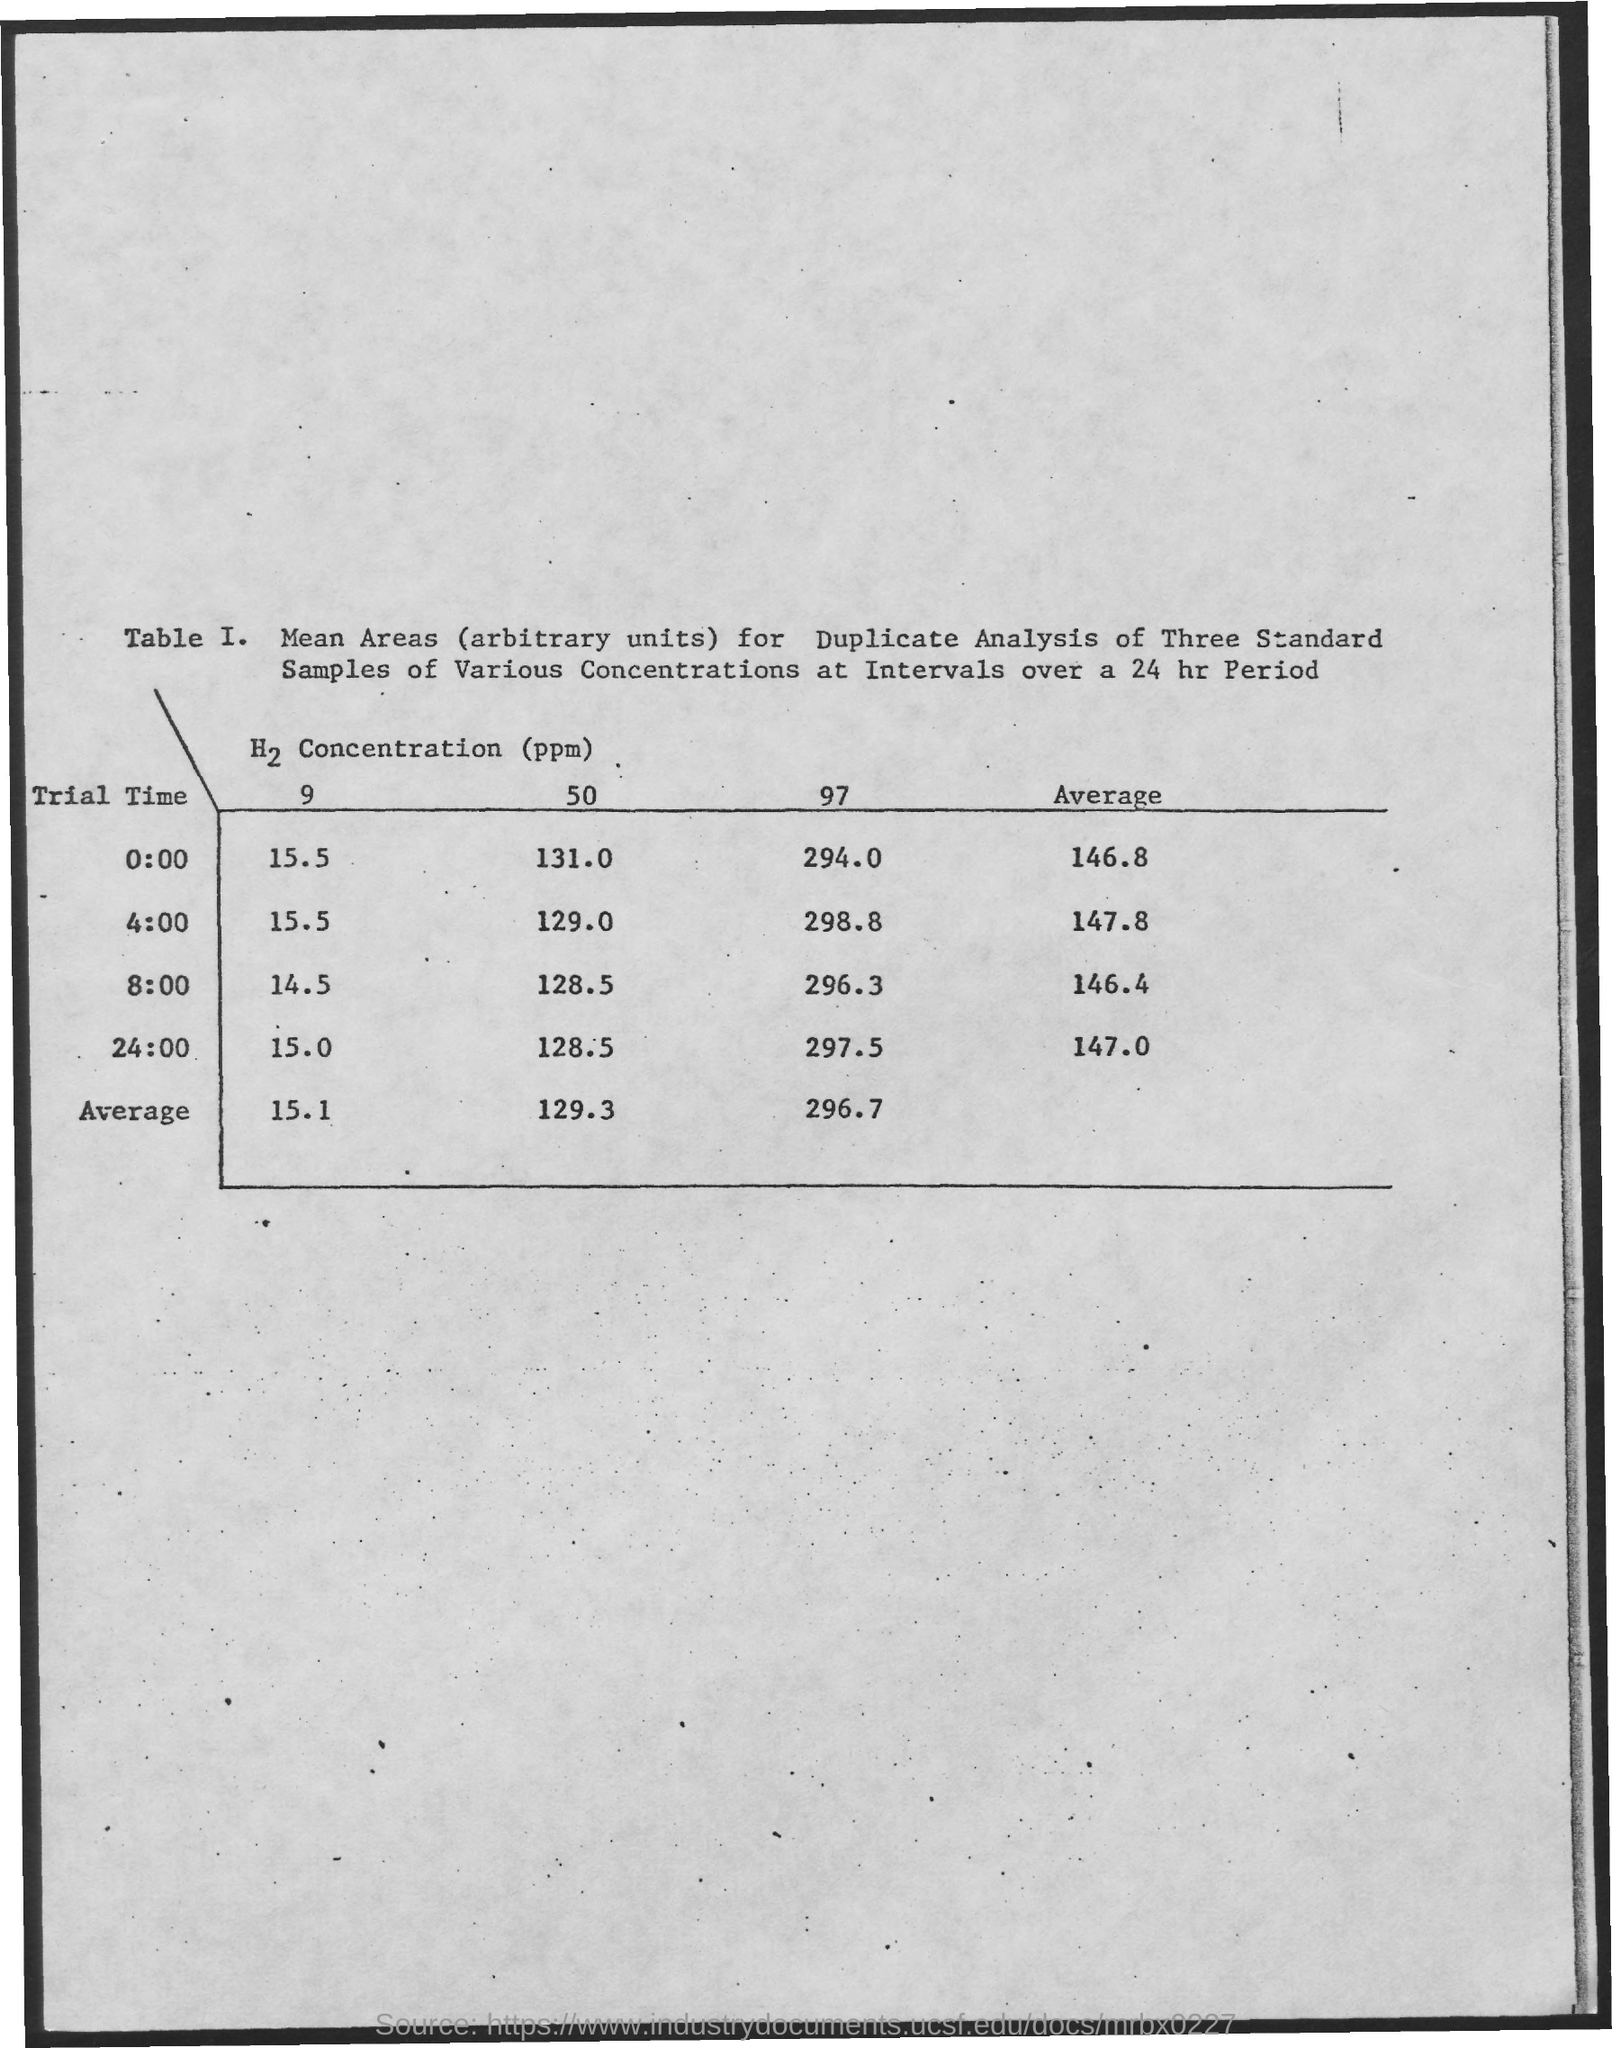Specify some key components in this picture. The average trial time is 147.0 seconds. What is the average time for a trial? 146.4 minutes. The average trial time is 146.8 seconds. The average trial time for all trials was 4:00, with a value of 147.8. 